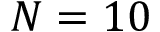<formula> <loc_0><loc_0><loc_500><loc_500>N = 1 0</formula> 